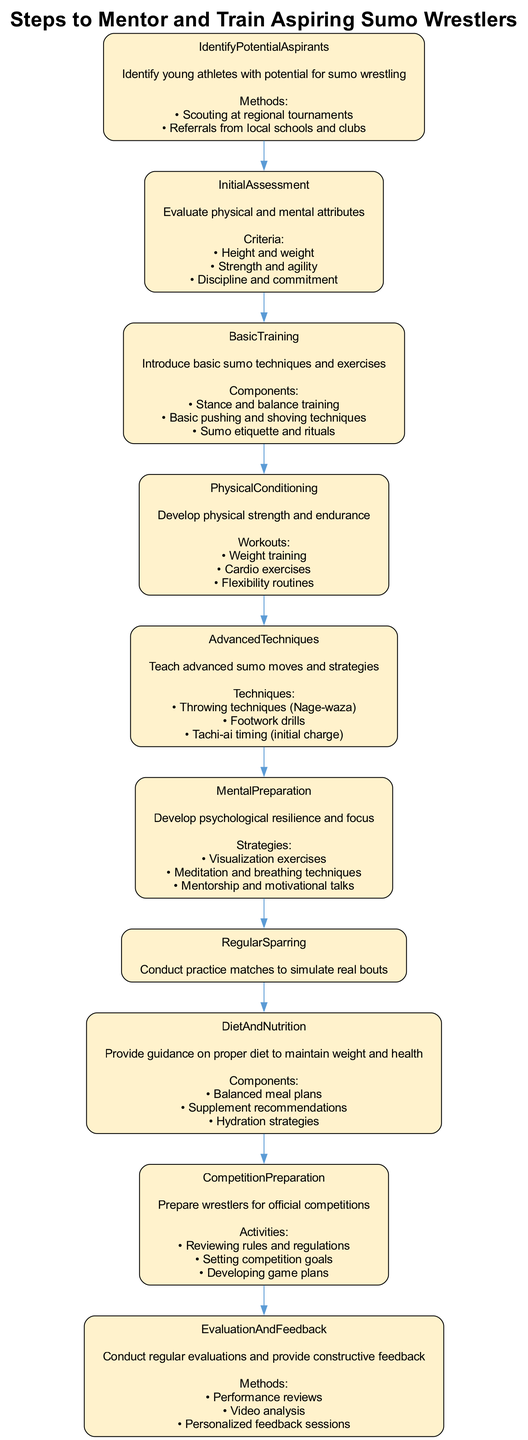What is the first step in the mentoring process? The first step is "IdentifyPotentialAspirants," as it appears at the top of the flow chart and initiates the process of mentoring aspiring sumo wrestlers.
Answer: IdentifyPotentialAspirants How many methods are listed for identifying potential aspirants? There are two methods listed: "Scouting at regional tournaments" and "Referrals from local schools and clubs," which can be counted directly from the node details.
Answer: 2 Which step includes visualization exercises? The step containing "Visualization exercises" is "MentalPreparation," where psychological resilience and focus are developed.
Answer: MentalPreparation What is the primary focus of the RegularSparring step? The primary focus areas outlined in the "RegularSparring" step include applying techniques in bouts, improving reaction time, and building match endurance. This indicates that the goal is to enhance practical experience in a match-like environment.
Answer: Applying techniques in bouts, Improving reaction time, Building match endurance Which two steps directly involve physical training? The two steps that involve physical training are "PhysicalConditioning" and "BasicTraining," as both focus on developing physical abilities essential for sumo wrestling.
Answer: PhysicalConditioning, BasicTraining What are the methods used for EvaluationAndFeedback? The methods listed for "EvaluationAndFeedback" are performance reviews, video analysis, and personalized feedback sessions. These methods emphasize the importance of constructive criticism and continuous improvement in the mentoring process.
Answer: Performance reviews, Video analysis, Personalized feedback sessions What comes after BasicTraining in the flowchart? Following "BasicTraining," the next step in the flowchart is "PhysicalConditioning," showing the progression from basic skills to enhancing physical capabilities for aspiring wrestlers.
Answer: PhysicalConditioning How many main steps are there in the training flow? There are ten main steps identified in the flow chart based on the various stages outlined in the mentoring process for sumo wrestlers. Each step contributes uniquely to the development of the athletes.
Answer: 10 What focuses on preparing wrestlers for official competitions? The step that focuses on preparing wrestlers for official competitions is "CompetitionPreparation," detailing necessary activities such as reviewing rules and developing game plans.
Answer: CompetitionPreparation 